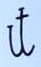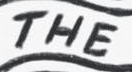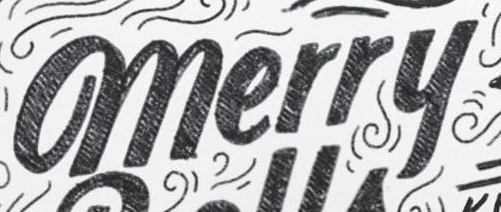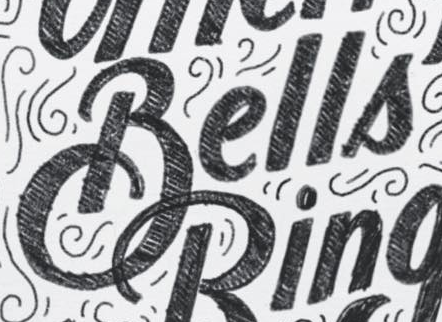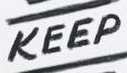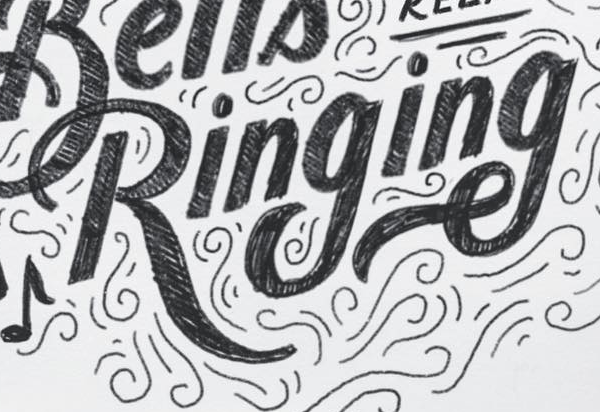What text appears in these images from left to right, separated by a semicolon? it; THE; merry; Bells; KEEP; Ringing 